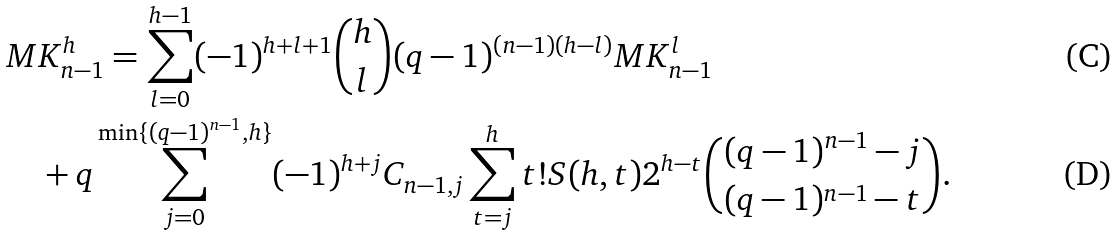<formula> <loc_0><loc_0><loc_500><loc_500>& M K _ { n - 1 } ^ { h } = \sum _ { l = 0 } ^ { h - 1 } ( - 1 ) ^ { h + l + 1 } { \binom { h } { l } } ( q - 1 ) ^ { ( n - 1 ) ( h - l ) } M K _ { n - 1 } ^ { l } \\ & \quad + q \sum _ { j = 0 } ^ { \min \{ ( q - 1 ) ^ { n - 1 } , h \} } ( - 1 ) ^ { h + j } C _ { n - 1 , j } \sum _ { t = j } ^ { h } t ! S ( h , t ) 2 ^ { h - t } { \binom { ( q - 1 ) ^ { n - 1 } - j } { ( q - 1 ) ^ { n - 1 } - t } } .</formula> 